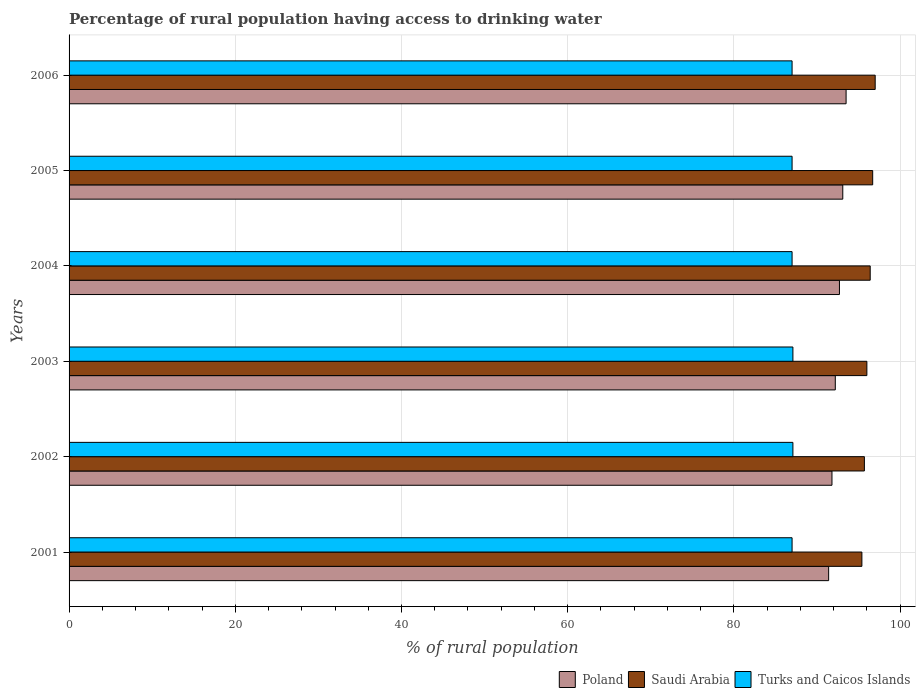How many different coloured bars are there?
Give a very brief answer. 3. How many groups of bars are there?
Your response must be concise. 6. Are the number of bars per tick equal to the number of legend labels?
Make the answer very short. Yes. Are the number of bars on each tick of the Y-axis equal?
Ensure brevity in your answer.  Yes. How many bars are there on the 3rd tick from the top?
Your answer should be very brief. 3. How many bars are there on the 1st tick from the bottom?
Your answer should be compact. 3. What is the label of the 4th group of bars from the top?
Give a very brief answer. 2003. What is the percentage of rural population having access to drinking water in Saudi Arabia in 2003?
Provide a short and direct response. 96. Across all years, what is the maximum percentage of rural population having access to drinking water in Saudi Arabia?
Give a very brief answer. 97. Across all years, what is the minimum percentage of rural population having access to drinking water in Saudi Arabia?
Give a very brief answer. 95.4. In which year was the percentage of rural population having access to drinking water in Turks and Caicos Islands maximum?
Keep it short and to the point. 2002. In which year was the percentage of rural population having access to drinking water in Turks and Caicos Islands minimum?
Provide a succinct answer. 2001. What is the total percentage of rural population having access to drinking water in Poland in the graph?
Provide a short and direct response. 554.7. What is the difference between the percentage of rural population having access to drinking water in Poland in 2001 and that in 2005?
Your answer should be compact. -1.7. What is the difference between the percentage of rural population having access to drinking water in Poland in 2006 and the percentage of rural population having access to drinking water in Saudi Arabia in 2001?
Give a very brief answer. -1.9. What is the average percentage of rural population having access to drinking water in Poland per year?
Keep it short and to the point. 92.45. What is the ratio of the percentage of rural population having access to drinking water in Turks and Caicos Islands in 2001 to that in 2003?
Give a very brief answer. 1. Is the percentage of rural population having access to drinking water in Poland in 2002 less than that in 2003?
Offer a very short reply. Yes. Is the difference between the percentage of rural population having access to drinking water in Saudi Arabia in 2002 and 2006 greater than the difference between the percentage of rural population having access to drinking water in Turks and Caicos Islands in 2002 and 2006?
Offer a terse response. No. What is the difference between the highest and the second highest percentage of rural population having access to drinking water in Poland?
Give a very brief answer. 0.4. What is the difference between the highest and the lowest percentage of rural population having access to drinking water in Poland?
Provide a short and direct response. 2.1. In how many years, is the percentage of rural population having access to drinking water in Turks and Caicos Islands greater than the average percentage of rural population having access to drinking water in Turks and Caicos Islands taken over all years?
Offer a terse response. 2. What does the 2nd bar from the bottom in 2003 represents?
Your answer should be compact. Saudi Arabia. Are all the bars in the graph horizontal?
Make the answer very short. Yes. How many years are there in the graph?
Keep it short and to the point. 6. Are the values on the major ticks of X-axis written in scientific E-notation?
Your answer should be very brief. No. Does the graph contain any zero values?
Offer a terse response. No. How many legend labels are there?
Your answer should be compact. 3. What is the title of the graph?
Your answer should be very brief. Percentage of rural population having access to drinking water. Does "Lebanon" appear as one of the legend labels in the graph?
Offer a terse response. No. What is the label or title of the X-axis?
Keep it short and to the point. % of rural population. What is the label or title of the Y-axis?
Give a very brief answer. Years. What is the % of rural population in Poland in 2001?
Offer a very short reply. 91.4. What is the % of rural population of Saudi Arabia in 2001?
Offer a terse response. 95.4. What is the % of rural population in Poland in 2002?
Your answer should be very brief. 91.8. What is the % of rural population in Saudi Arabia in 2002?
Your answer should be very brief. 95.7. What is the % of rural population of Turks and Caicos Islands in 2002?
Provide a short and direct response. 87.1. What is the % of rural population in Poland in 2003?
Your answer should be very brief. 92.2. What is the % of rural population of Saudi Arabia in 2003?
Your answer should be compact. 96. What is the % of rural population in Turks and Caicos Islands in 2003?
Keep it short and to the point. 87.1. What is the % of rural population in Poland in 2004?
Provide a short and direct response. 92.7. What is the % of rural population in Saudi Arabia in 2004?
Ensure brevity in your answer.  96.4. What is the % of rural population of Turks and Caicos Islands in 2004?
Make the answer very short. 87. What is the % of rural population of Poland in 2005?
Keep it short and to the point. 93.1. What is the % of rural population of Saudi Arabia in 2005?
Provide a short and direct response. 96.7. What is the % of rural population of Poland in 2006?
Offer a very short reply. 93.5. What is the % of rural population of Saudi Arabia in 2006?
Provide a succinct answer. 97. What is the % of rural population of Turks and Caicos Islands in 2006?
Ensure brevity in your answer.  87. Across all years, what is the maximum % of rural population in Poland?
Offer a very short reply. 93.5. Across all years, what is the maximum % of rural population of Saudi Arabia?
Offer a very short reply. 97. Across all years, what is the maximum % of rural population in Turks and Caicos Islands?
Offer a very short reply. 87.1. Across all years, what is the minimum % of rural population in Poland?
Make the answer very short. 91.4. Across all years, what is the minimum % of rural population in Saudi Arabia?
Ensure brevity in your answer.  95.4. Across all years, what is the minimum % of rural population of Turks and Caicos Islands?
Provide a succinct answer. 87. What is the total % of rural population of Poland in the graph?
Ensure brevity in your answer.  554.7. What is the total % of rural population of Saudi Arabia in the graph?
Provide a short and direct response. 577.2. What is the total % of rural population in Turks and Caicos Islands in the graph?
Provide a succinct answer. 522.2. What is the difference between the % of rural population of Poland in 2001 and that in 2002?
Provide a succinct answer. -0.4. What is the difference between the % of rural population in Saudi Arabia in 2001 and that in 2002?
Offer a terse response. -0.3. What is the difference between the % of rural population of Poland in 2001 and that in 2004?
Give a very brief answer. -1.3. What is the difference between the % of rural population of Saudi Arabia in 2001 and that in 2004?
Ensure brevity in your answer.  -1. What is the difference between the % of rural population of Saudi Arabia in 2001 and that in 2005?
Your answer should be compact. -1.3. What is the difference between the % of rural population in Turks and Caicos Islands in 2001 and that in 2005?
Your answer should be compact. 0. What is the difference between the % of rural population of Poland in 2001 and that in 2006?
Your answer should be compact. -2.1. What is the difference between the % of rural population of Turks and Caicos Islands in 2001 and that in 2006?
Ensure brevity in your answer.  0. What is the difference between the % of rural population in Poland in 2002 and that in 2003?
Make the answer very short. -0.4. What is the difference between the % of rural population in Poland in 2002 and that in 2004?
Your answer should be compact. -0.9. What is the difference between the % of rural population of Turks and Caicos Islands in 2002 and that in 2004?
Your answer should be compact. 0.1. What is the difference between the % of rural population in Turks and Caicos Islands in 2002 and that in 2005?
Keep it short and to the point. 0.1. What is the difference between the % of rural population of Saudi Arabia in 2002 and that in 2006?
Provide a succinct answer. -1.3. What is the difference between the % of rural population in Poland in 2003 and that in 2004?
Provide a succinct answer. -0.5. What is the difference between the % of rural population in Poland in 2003 and that in 2005?
Offer a very short reply. -0.9. What is the difference between the % of rural population in Turks and Caicos Islands in 2003 and that in 2005?
Make the answer very short. 0.1. What is the difference between the % of rural population in Saudi Arabia in 2004 and that in 2005?
Offer a very short reply. -0.3. What is the difference between the % of rural population of Poland in 2004 and that in 2006?
Ensure brevity in your answer.  -0.8. What is the difference between the % of rural population in Poland in 2005 and that in 2006?
Give a very brief answer. -0.4. What is the difference between the % of rural population in Poland in 2001 and the % of rural population in Saudi Arabia in 2002?
Your response must be concise. -4.3. What is the difference between the % of rural population of Poland in 2001 and the % of rural population of Turks and Caicos Islands in 2002?
Give a very brief answer. 4.3. What is the difference between the % of rural population in Poland in 2001 and the % of rural population in Saudi Arabia in 2003?
Ensure brevity in your answer.  -4.6. What is the difference between the % of rural population of Poland in 2001 and the % of rural population of Turks and Caicos Islands in 2005?
Your answer should be very brief. 4.4. What is the difference between the % of rural population of Saudi Arabia in 2001 and the % of rural population of Turks and Caicos Islands in 2005?
Keep it short and to the point. 8.4. What is the difference between the % of rural population of Poland in 2001 and the % of rural population of Saudi Arabia in 2006?
Offer a terse response. -5.6. What is the difference between the % of rural population of Poland in 2001 and the % of rural population of Turks and Caicos Islands in 2006?
Provide a succinct answer. 4.4. What is the difference between the % of rural population in Saudi Arabia in 2001 and the % of rural population in Turks and Caicos Islands in 2006?
Make the answer very short. 8.4. What is the difference between the % of rural population in Poland in 2002 and the % of rural population in Turks and Caicos Islands in 2003?
Your response must be concise. 4.7. What is the difference between the % of rural population of Saudi Arabia in 2002 and the % of rural population of Turks and Caicos Islands in 2003?
Keep it short and to the point. 8.6. What is the difference between the % of rural population in Poland in 2002 and the % of rural population in Turks and Caicos Islands in 2004?
Make the answer very short. 4.8. What is the difference between the % of rural population of Saudi Arabia in 2002 and the % of rural population of Turks and Caicos Islands in 2005?
Offer a terse response. 8.7. What is the difference between the % of rural population in Poland in 2003 and the % of rural population in Saudi Arabia in 2005?
Give a very brief answer. -4.5. What is the difference between the % of rural population in Saudi Arabia in 2003 and the % of rural population in Turks and Caicos Islands in 2005?
Make the answer very short. 9. What is the difference between the % of rural population of Poland in 2003 and the % of rural population of Turks and Caicos Islands in 2006?
Give a very brief answer. 5.2. What is the difference between the % of rural population in Poland in 2004 and the % of rural population in Saudi Arabia in 2005?
Give a very brief answer. -4. What is the difference between the % of rural population of Poland in 2004 and the % of rural population of Turks and Caicos Islands in 2005?
Give a very brief answer. 5.7. What is the difference between the % of rural population in Saudi Arabia in 2005 and the % of rural population in Turks and Caicos Islands in 2006?
Offer a terse response. 9.7. What is the average % of rural population of Poland per year?
Your answer should be compact. 92.45. What is the average % of rural population of Saudi Arabia per year?
Make the answer very short. 96.2. What is the average % of rural population of Turks and Caicos Islands per year?
Your answer should be compact. 87.03. In the year 2001, what is the difference between the % of rural population in Poland and % of rural population in Turks and Caicos Islands?
Your answer should be very brief. 4.4. In the year 2001, what is the difference between the % of rural population of Saudi Arabia and % of rural population of Turks and Caicos Islands?
Ensure brevity in your answer.  8.4. In the year 2002, what is the difference between the % of rural population in Poland and % of rural population in Saudi Arabia?
Offer a terse response. -3.9. In the year 2002, what is the difference between the % of rural population of Poland and % of rural population of Turks and Caicos Islands?
Your answer should be compact. 4.7. In the year 2003, what is the difference between the % of rural population in Poland and % of rural population in Saudi Arabia?
Your answer should be very brief. -3.8. In the year 2003, what is the difference between the % of rural population of Poland and % of rural population of Turks and Caicos Islands?
Offer a very short reply. 5.1. In the year 2004, what is the difference between the % of rural population of Poland and % of rural population of Saudi Arabia?
Give a very brief answer. -3.7. In the year 2004, what is the difference between the % of rural population in Poland and % of rural population in Turks and Caicos Islands?
Your answer should be very brief. 5.7. In the year 2004, what is the difference between the % of rural population in Saudi Arabia and % of rural population in Turks and Caicos Islands?
Your answer should be very brief. 9.4. In the year 2005, what is the difference between the % of rural population in Poland and % of rural population in Saudi Arabia?
Ensure brevity in your answer.  -3.6. What is the ratio of the % of rural population of Poland in 2001 to that in 2002?
Offer a very short reply. 1. What is the ratio of the % of rural population of Turks and Caicos Islands in 2001 to that in 2002?
Provide a short and direct response. 1. What is the ratio of the % of rural population in Turks and Caicos Islands in 2001 to that in 2003?
Make the answer very short. 1. What is the ratio of the % of rural population in Saudi Arabia in 2001 to that in 2004?
Offer a very short reply. 0.99. What is the ratio of the % of rural population in Turks and Caicos Islands in 2001 to that in 2004?
Keep it short and to the point. 1. What is the ratio of the % of rural population in Poland in 2001 to that in 2005?
Your answer should be compact. 0.98. What is the ratio of the % of rural population in Saudi Arabia in 2001 to that in 2005?
Your response must be concise. 0.99. What is the ratio of the % of rural population of Turks and Caicos Islands in 2001 to that in 2005?
Provide a short and direct response. 1. What is the ratio of the % of rural population in Poland in 2001 to that in 2006?
Provide a short and direct response. 0.98. What is the ratio of the % of rural population in Saudi Arabia in 2001 to that in 2006?
Make the answer very short. 0.98. What is the ratio of the % of rural population in Saudi Arabia in 2002 to that in 2003?
Ensure brevity in your answer.  1. What is the ratio of the % of rural population of Turks and Caicos Islands in 2002 to that in 2003?
Ensure brevity in your answer.  1. What is the ratio of the % of rural population in Poland in 2002 to that in 2004?
Offer a very short reply. 0.99. What is the ratio of the % of rural population of Saudi Arabia in 2002 to that in 2004?
Your answer should be compact. 0.99. What is the ratio of the % of rural population in Turks and Caicos Islands in 2002 to that in 2004?
Keep it short and to the point. 1. What is the ratio of the % of rural population of Poland in 2002 to that in 2005?
Offer a terse response. 0.99. What is the ratio of the % of rural population in Poland in 2002 to that in 2006?
Offer a very short reply. 0.98. What is the ratio of the % of rural population in Saudi Arabia in 2002 to that in 2006?
Make the answer very short. 0.99. What is the ratio of the % of rural population of Turks and Caicos Islands in 2003 to that in 2004?
Your answer should be compact. 1. What is the ratio of the % of rural population in Poland in 2003 to that in 2005?
Your answer should be very brief. 0.99. What is the ratio of the % of rural population in Poland in 2003 to that in 2006?
Your response must be concise. 0.99. What is the ratio of the % of rural population of Poland in 2004 to that in 2005?
Provide a short and direct response. 1. What is the ratio of the % of rural population in Saudi Arabia in 2004 to that in 2005?
Give a very brief answer. 1. What is the ratio of the % of rural population of Turks and Caicos Islands in 2004 to that in 2005?
Your response must be concise. 1. What is the ratio of the % of rural population of Saudi Arabia in 2004 to that in 2006?
Provide a short and direct response. 0.99. What is the ratio of the % of rural population of Turks and Caicos Islands in 2004 to that in 2006?
Your answer should be compact. 1. What is the ratio of the % of rural population of Turks and Caicos Islands in 2005 to that in 2006?
Make the answer very short. 1. What is the difference between the highest and the lowest % of rural population of Saudi Arabia?
Make the answer very short. 1.6. 